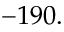Convert formula to latex. <formula><loc_0><loc_0><loc_500><loc_500>- 1 9 0 .</formula> 